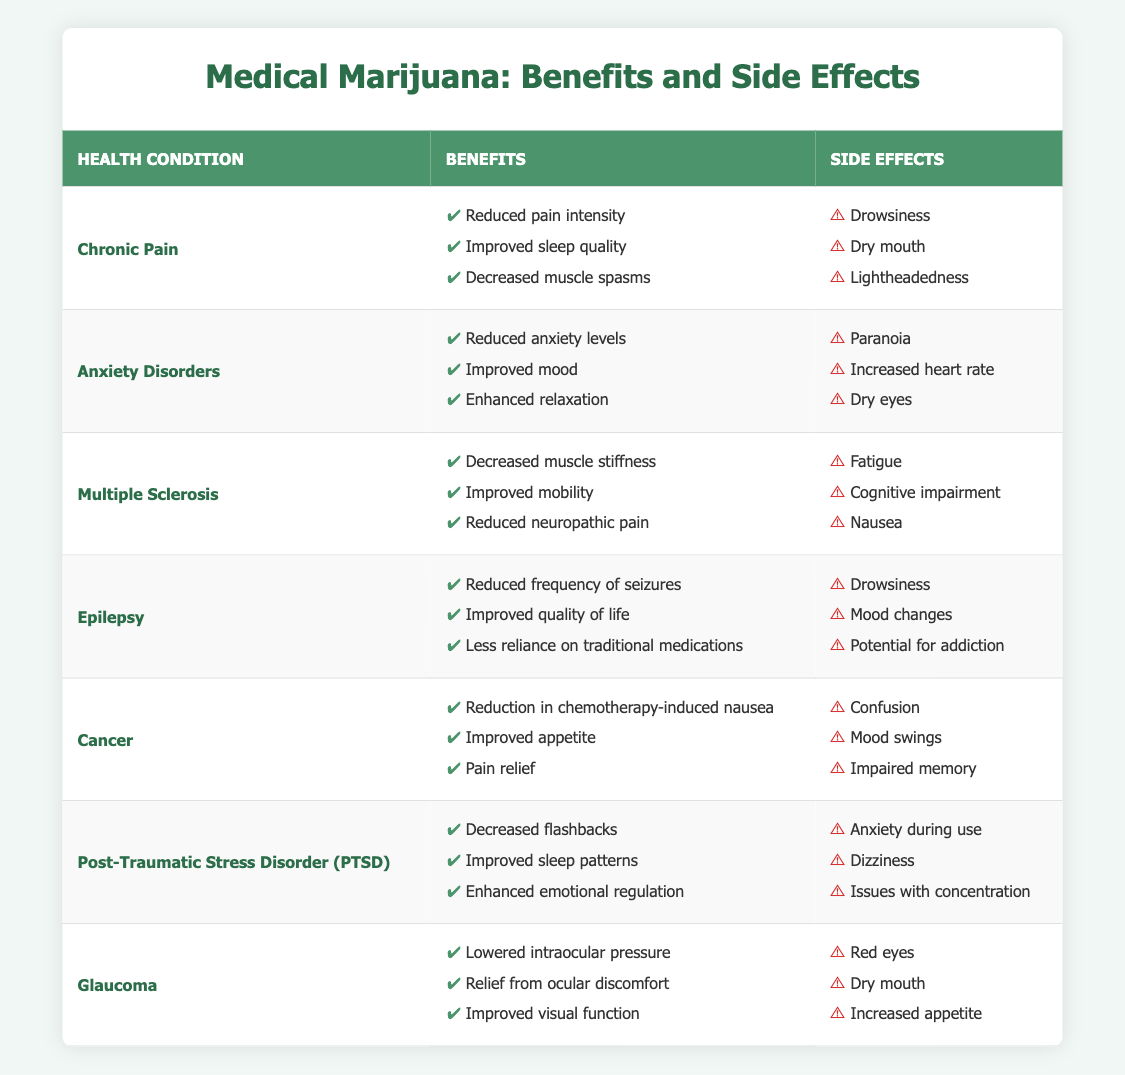What benefits are reported for Chronic Pain? The table lists the benefits for Chronic Pain as follows: Reduced pain intensity, Improved sleep quality, and Decreased muscle spasms.
Answer: Reduced pain intensity, Improved sleep quality, Decreased muscle spasms What side effects are associated with Anxiety Disorders? The table outlines the side effects for Anxiety Disorders as: Paranoia, Increased heart rate, and Dry eyes.
Answer: Paranoia, Increased heart rate, Dry eyes Is "Improved mobility" a benefit for Multiple Sclerosis? Looking at the table, "Improved mobility" is indeed listed as one of the benefits for Multiple Sclerosis.
Answer: Yes Which health condition has "Drowsiness" as a side effect? The table shows that both Chronic Pain and Epilepsy list "Drowsiness" as a side effect.
Answer: Chronic Pain, Epilepsy What are the total number of benefits listed for Cancer? According to the table, Cancer has three benefits listed: Reduction in chemotherapy-induced nausea, Improved appetite, and Pain relief. Therefore, the total number of benefits is 3.
Answer: 3 Which health condition has the most side effects? By examining the side effects for each condition: Chronic Pain (3), Anxiety Disorders (3), Multiple Sclerosis (3), Epilepsy (3), Cancer (3), PTSD (3), and Glaucoma (3) all have the same number of side effects. Therefore, there is no single health condition with more side effects; they are all equal at 3.
Answer: None (equal) Are there any health conditions where the benefits include "Emotional regulation"? The table shows that "Enhanced emotional regulation" is a benefit listed under Post-Traumatic Stress Disorder (PTSD).
Answer: Yes, PTSD What is the common side effect across Chronic Pain and Glaucoma? The common side effect listed for both Chronic Pain and Glaucoma is "Dry mouth."
Answer: Dry mouth How many total unique health conditions are listed in the table? The table contains 7 unique health conditions: Chronic Pain, Anxiety Disorders, Multiple Sclerosis, Epilepsy, Cancer, PTSD, and Glaucoma, giving a total of 7.
Answer: 7 Which health condition has both "Mood swings" and "Impaired memory" listed as side effects? The side effects "Mood swings" and "Impaired memory" are both listed under the health condition Cancer.
Answer: Cancer 